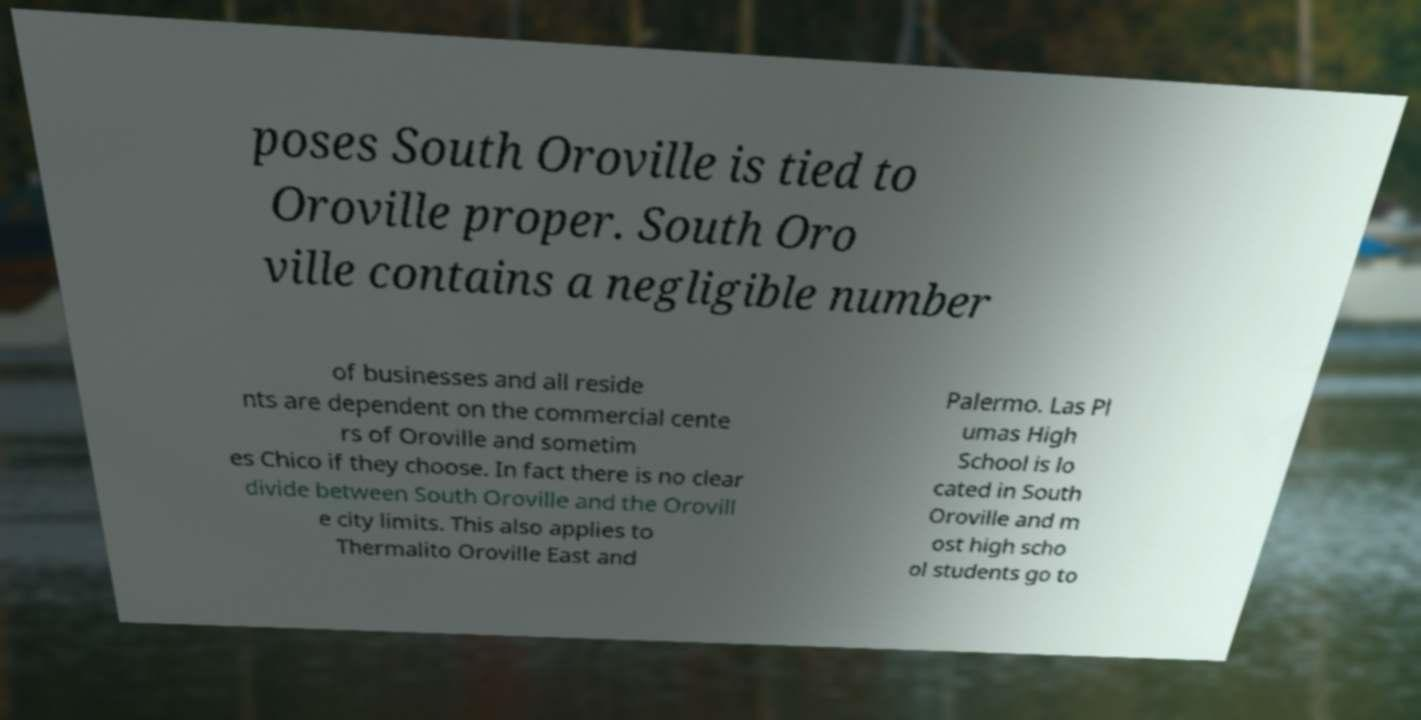Please identify and transcribe the text found in this image. poses South Oroville is tied to Oroville proper. South Oro ville contains a negligible number of businesses and all reside nts are dependent on the commercial cente rs of Oroville and sometim es Chico if they choose. In fact there is no clear divide between South Oroville and the Orovill e city limits. This also applies to Thermalito Oroville East and Palermo. Las Pl umas High School is lo cated in South Oroville and m ost high scho ol students go to 